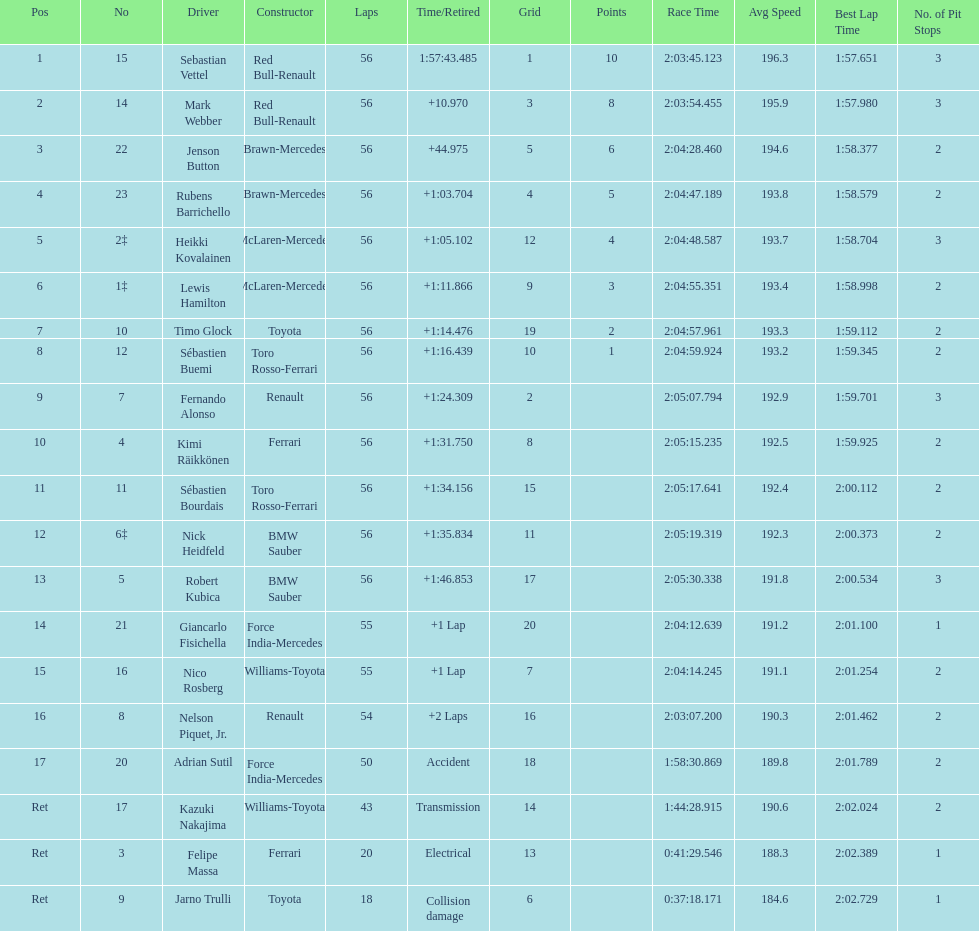How many laps in total is the race? 56. 